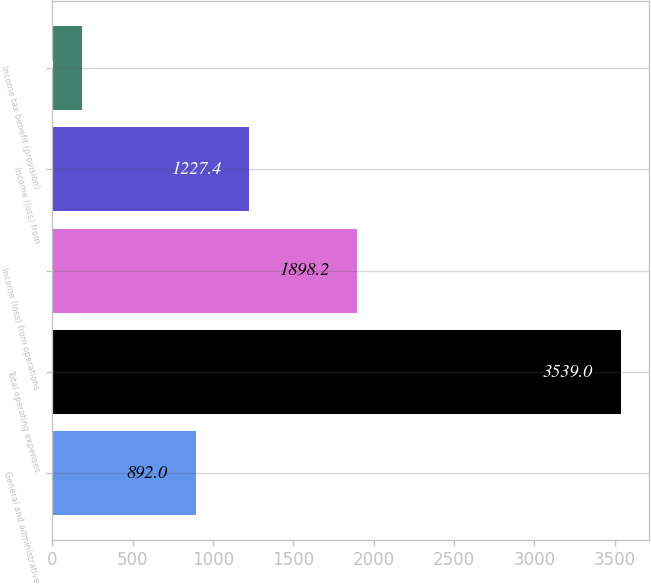Convert chart to OTSL. <chart><loc_0><loc_0><loc_500><loc_500><bar_chart><fcel>General and administrative<fcel>Total operating expenses<fcel>Income (loss) from operations<fcel>Income (loss) from<fcel>Income tax benefit (provision)<nl><fcel>892<fcel>3539<fcel>1898.2<fcel>1227.4<fcel>185<nl></chart> 